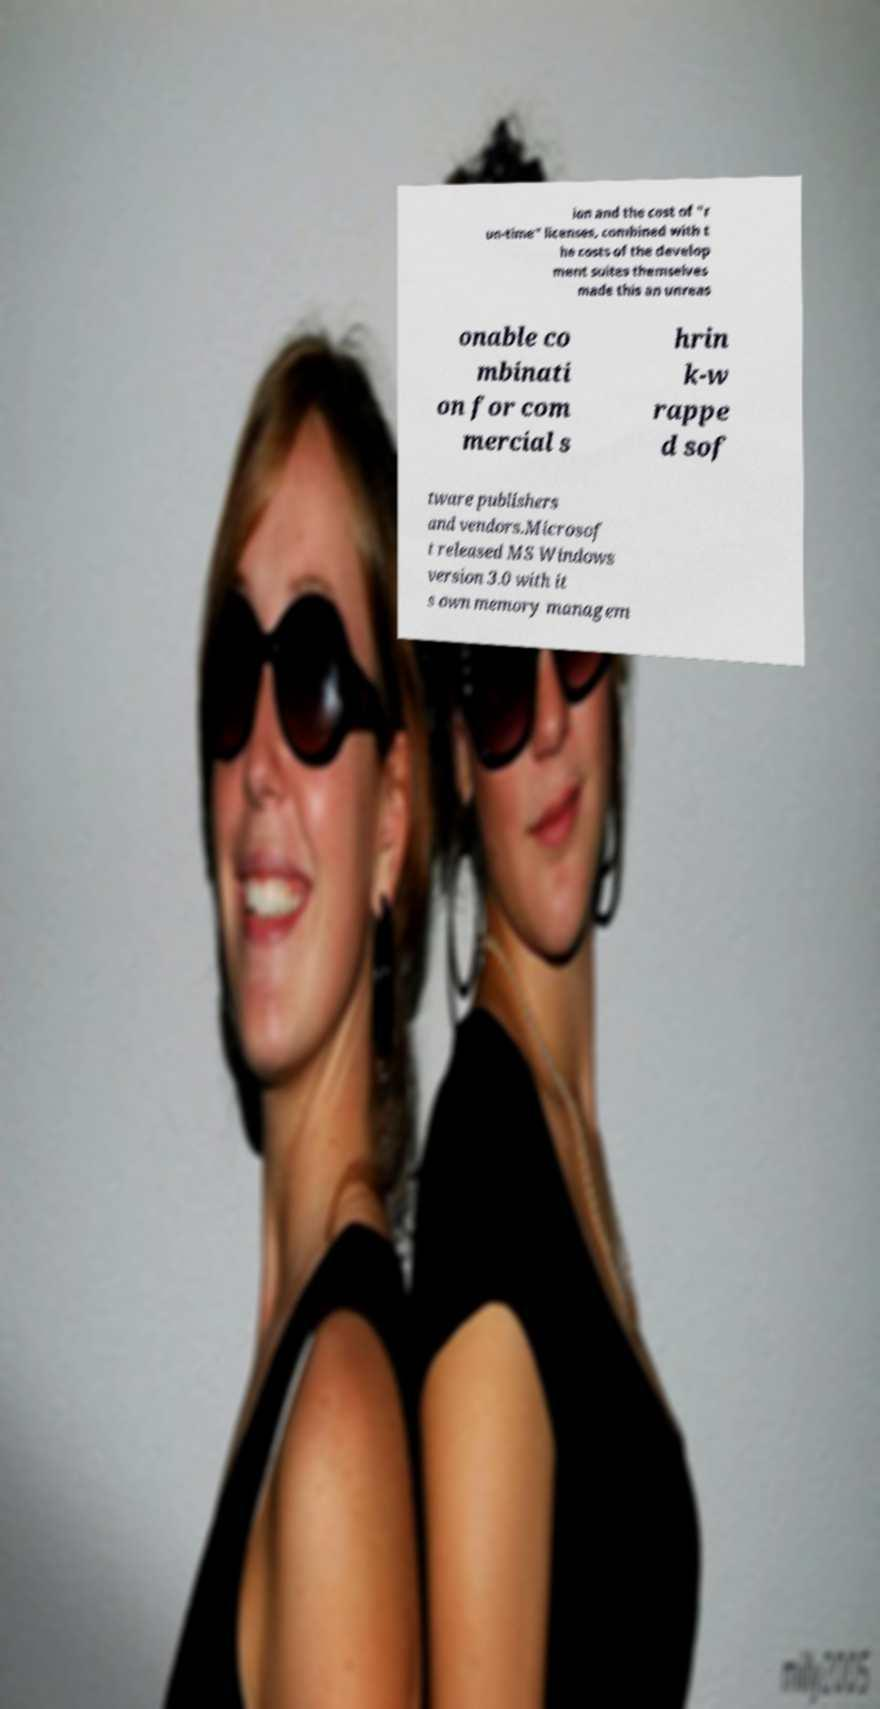What messages or text are displayed in this image? I need them in a readable, typed format. ion and the cost of "r un-time" licenses, combined with t he costs of the develop ment suites themselves made this an unreas onable co mbinati on for com mercial s hrin k-w rappe d sof tware publishers and vendors.Microsof t released MS Windows version 3.0 with it s own memory managem 